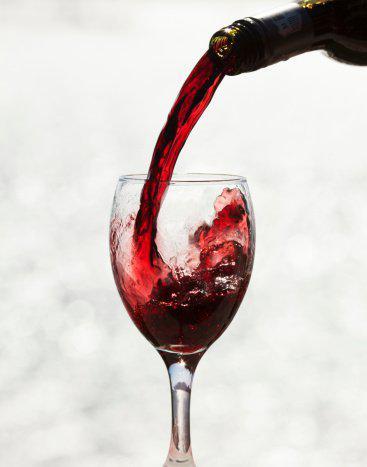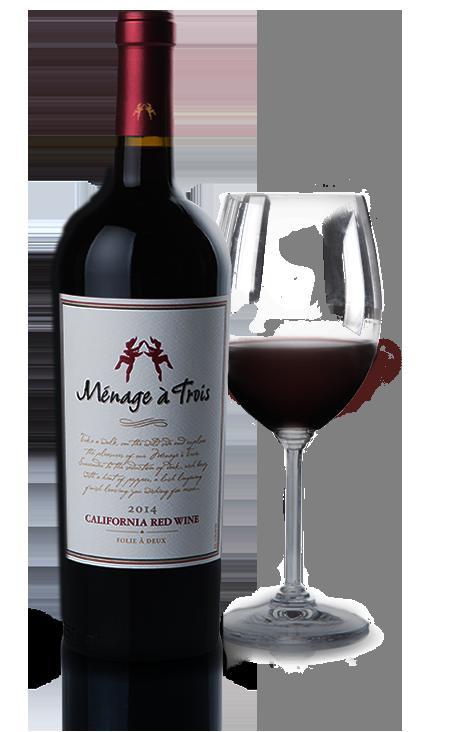The first image is the image on the left, the second image is the image on the right. Given the left and right images, does the statement "The left image shows burgundy wine pouring into a glass." hold true? Answer yes or no. Yes. 